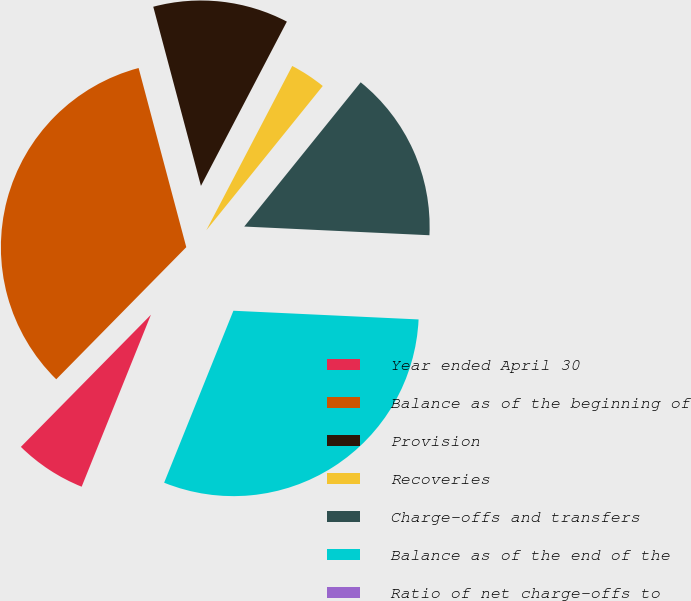Convert chart. <chart><loc_0><loc_0><loc_500><loc_500><pie_chart><fcel>Year ended April 30<fcel>Balance as of the beginning of<fcel>Provision<fcel>Recoveries<fcel>Charge-offs and transfers<fcel>Balance as of the end of the<fcel>Ratio of net charge-offs to<nl><fcel>6.28%<fcel>33.49%<fcel>11.81%<fcel>3.14%<fcel>14.94%<fcel>30.35%<fcel>0.0%<nl></chart> 